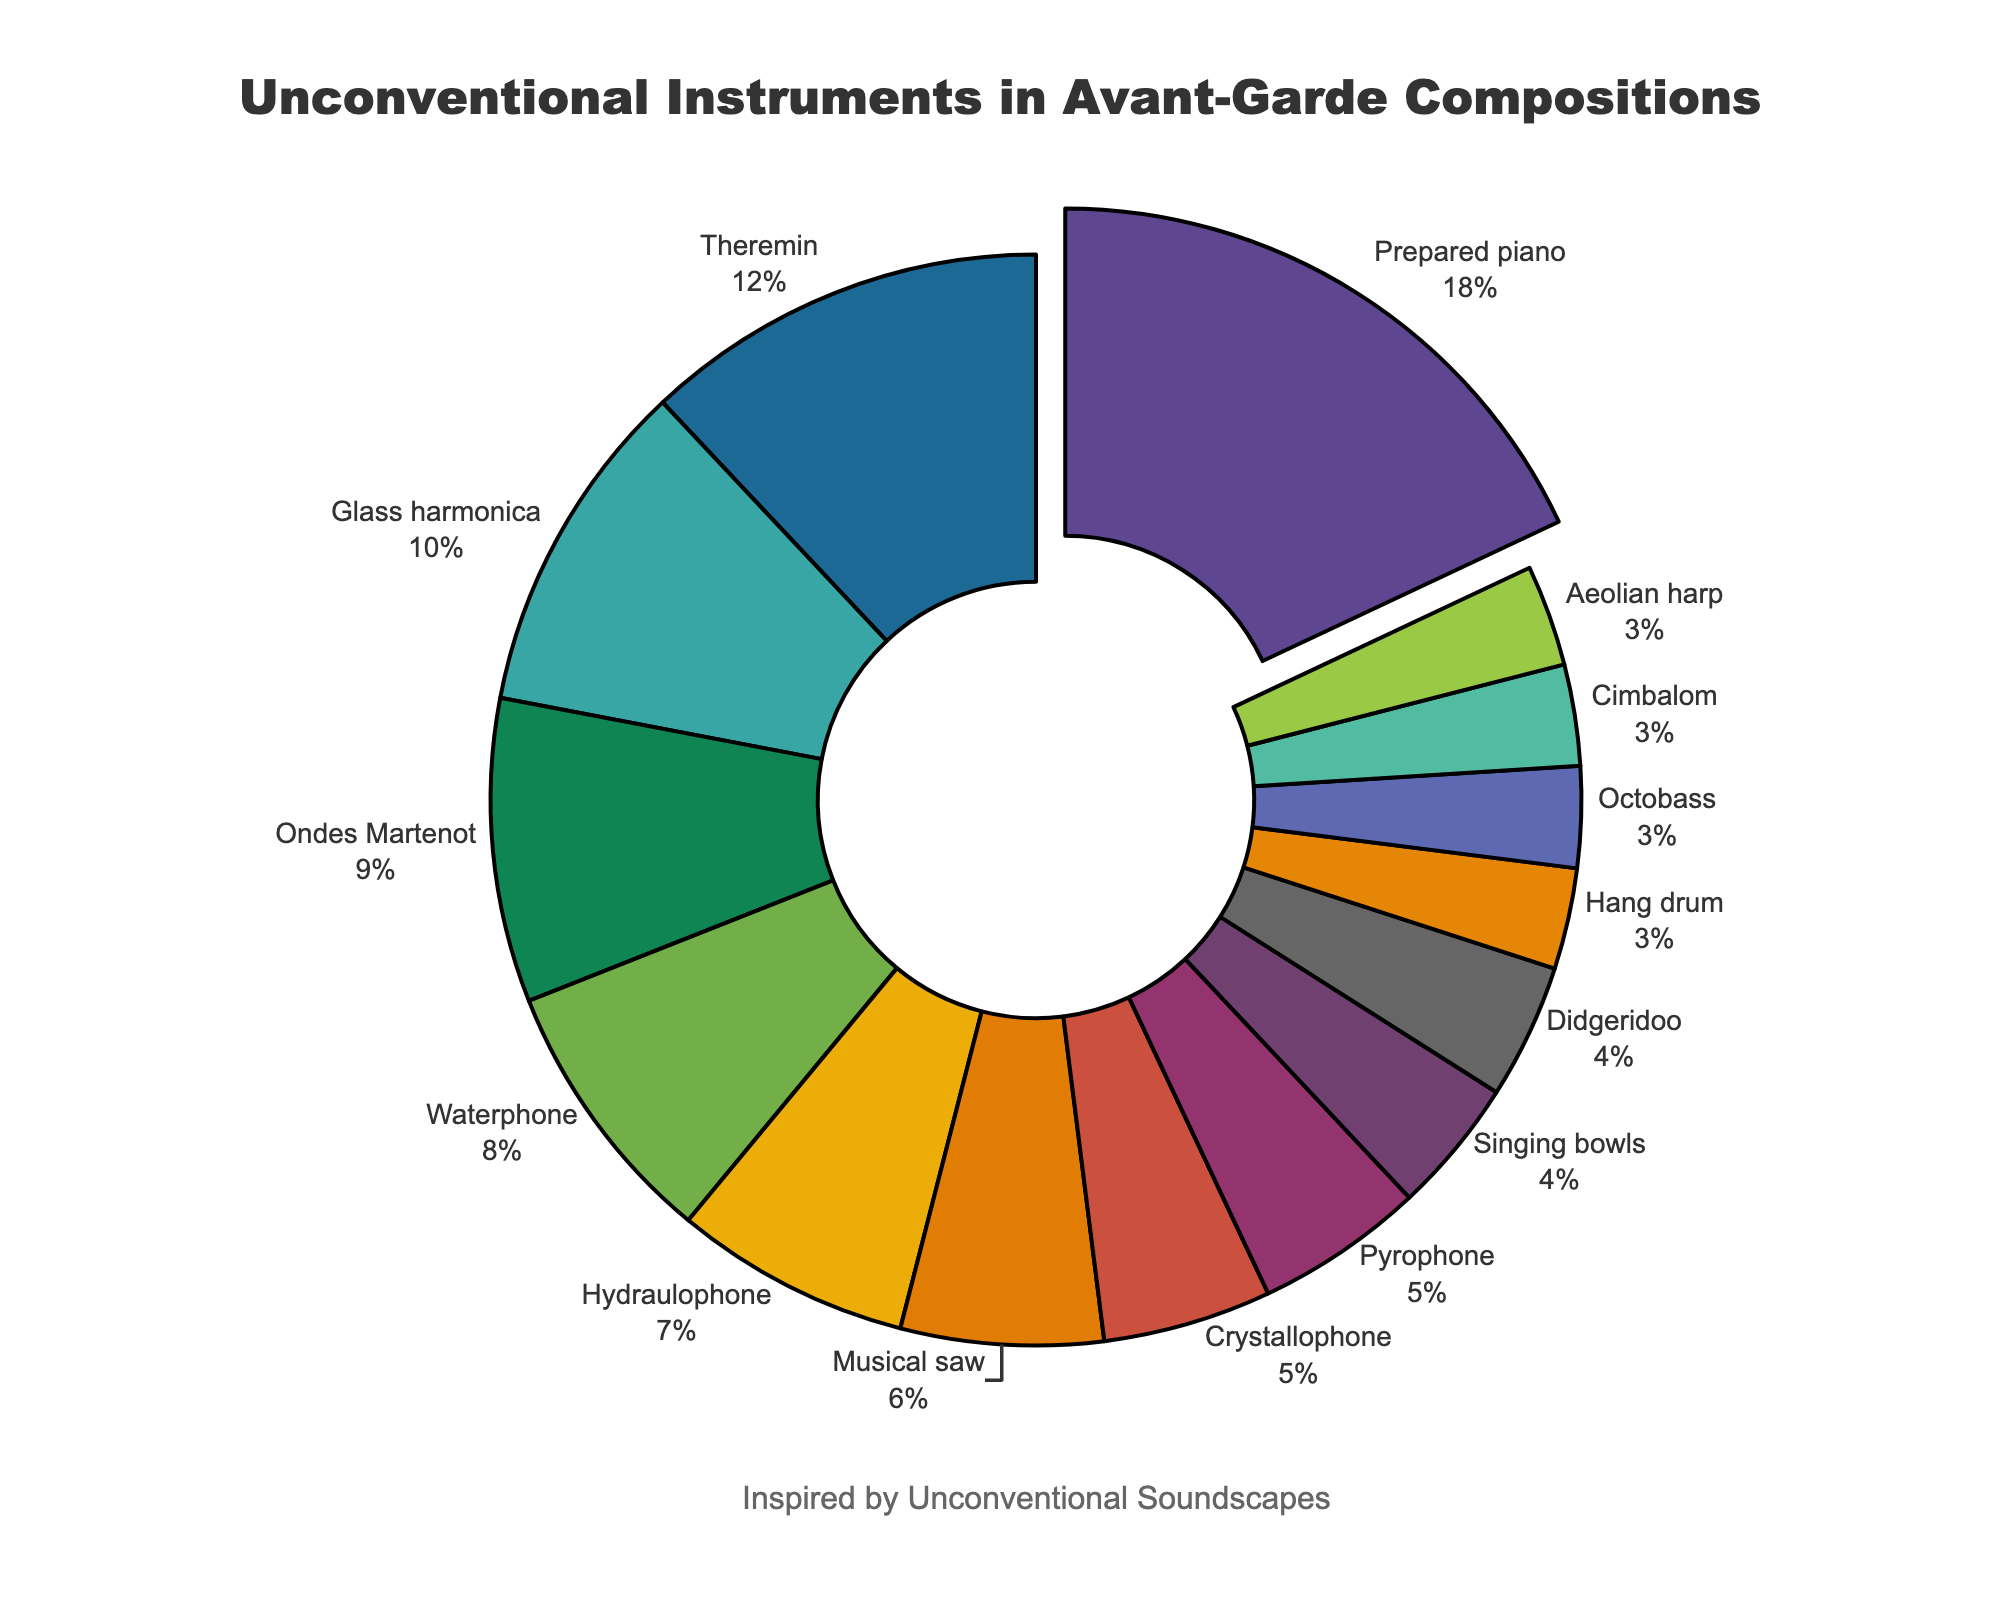What's the most prominently used unconventional instrument? The instrument with the highest percentage is the most prominently used. This can be seen by looking at the largest slice of the pie chart. Here, the slice for the Prepared piano is largest.
Answer: Prepared piano What percentage of the instruments have a usage of less than 5%? To find this, count all the instruments with percentages below 5% and divide by the total number of instruments. There are 4 such instruments out of 15. Calculate as: (4/15) * 100 = 26.67%.
Answer: 26.67% How much more is the percentage of Prepared piano compared to the Ondes Martenot? Subtract the percentage of Ondes Martenot from Prepared piano. Prepared piano has 18% and Ondes Martenot has 9%. So, 18% - 9% = 9%.
Answer: 9% Which unconventional instrument pairs up to a combined total of 15%? Sum the percentages of different pairs and check which pairs equal 15%. In this case, the percentages of Crystallophone (5%) and Pyrophone (5%) together with Singing bowls (4%) add up to 14%. Adding Hang drum (3%) makes it (5% + 5% + 4% = 14%). One of the correct pairs is Crystallophone and Pyrophone (5% + 5%) combined with Hang drum (3%).
Answer: Crystallophone, Pyrophone, and Hang drum Which instrument has just a bit more usage than the Waterphone? The Waterphone has an 8% usage. The instrument with the next highest percentage is the Hydraulophone at 7%.
Answer: Hydraulophone What is the total percentage for the three least used instruments collectively? Identify the three least used instruments, which are Hang drum, Octobass, and Cimbalom, each with 3%. Sum their percentages: 3% + 3% + 3% = 9%.
Answer: 9% How do the percentages of Prepared piano and Theremin compare? Prepared piano is at 18% and Theremin is at 12%. Prepared piano has a higher percentage than Theremin.
Answer: Prepared piano > Theremin Which instrument has the highest usage among those with less than 10% usage? Filter out all instruments with less than 10% usage and find the one with the highest percentage. Among them, Theremin has the highest with 9%.
Answer: Theremin Compare the combined percentage of Glass harmonica, Waterphone, and Hydraulophone to Prepared piano. Add the percentages of Glass harmonica (10%), Waterphone (8%), and Hydraulophone (7%) and compare to Prepared piano (18%). Calculated as: 10% + 8% + 7% = 25%, which is greater than 18%.
Answer: 25% > 18% 